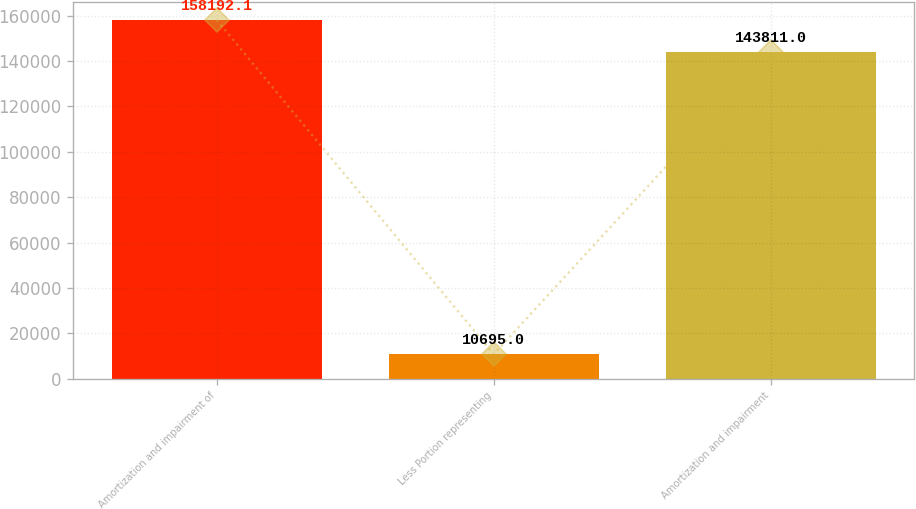Convert chart to OTSL. <chart><loc_0><loc_0><loc_500><loc_500><bar_chart><fcel>Amortization and impairment of<fcel>Less Portion representing<fcel>Amortization and impairment<nl><fcel>158192<fcel>10695<fcel>143811<nl></chart> 